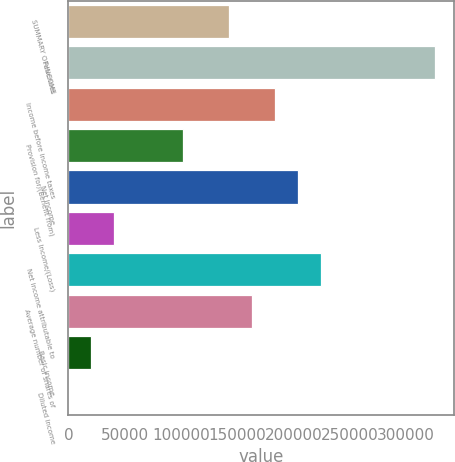<chart> <loc_0><loc_0><loc_500><loc_500><bar_chart><fcel>SUMMARY OF INCOME<fcel>Revenues<fcel>Income before income taxes<fcel>Provision for/(Benefit from)<fcel>Net income<fcel>Less Income/(Loss)<fcel>Net income attributable to<fcel>Average number of shares of<fcel>Basic income<fcel>Diluted income<nl><fcel>142734<fcel>326247<fcel>183515<fcel>101953<fcel>203905<fcel>40782.4<fcel>224295<fcel>163124<fcel>20392.1<fcel>1.77<nl></chart> 